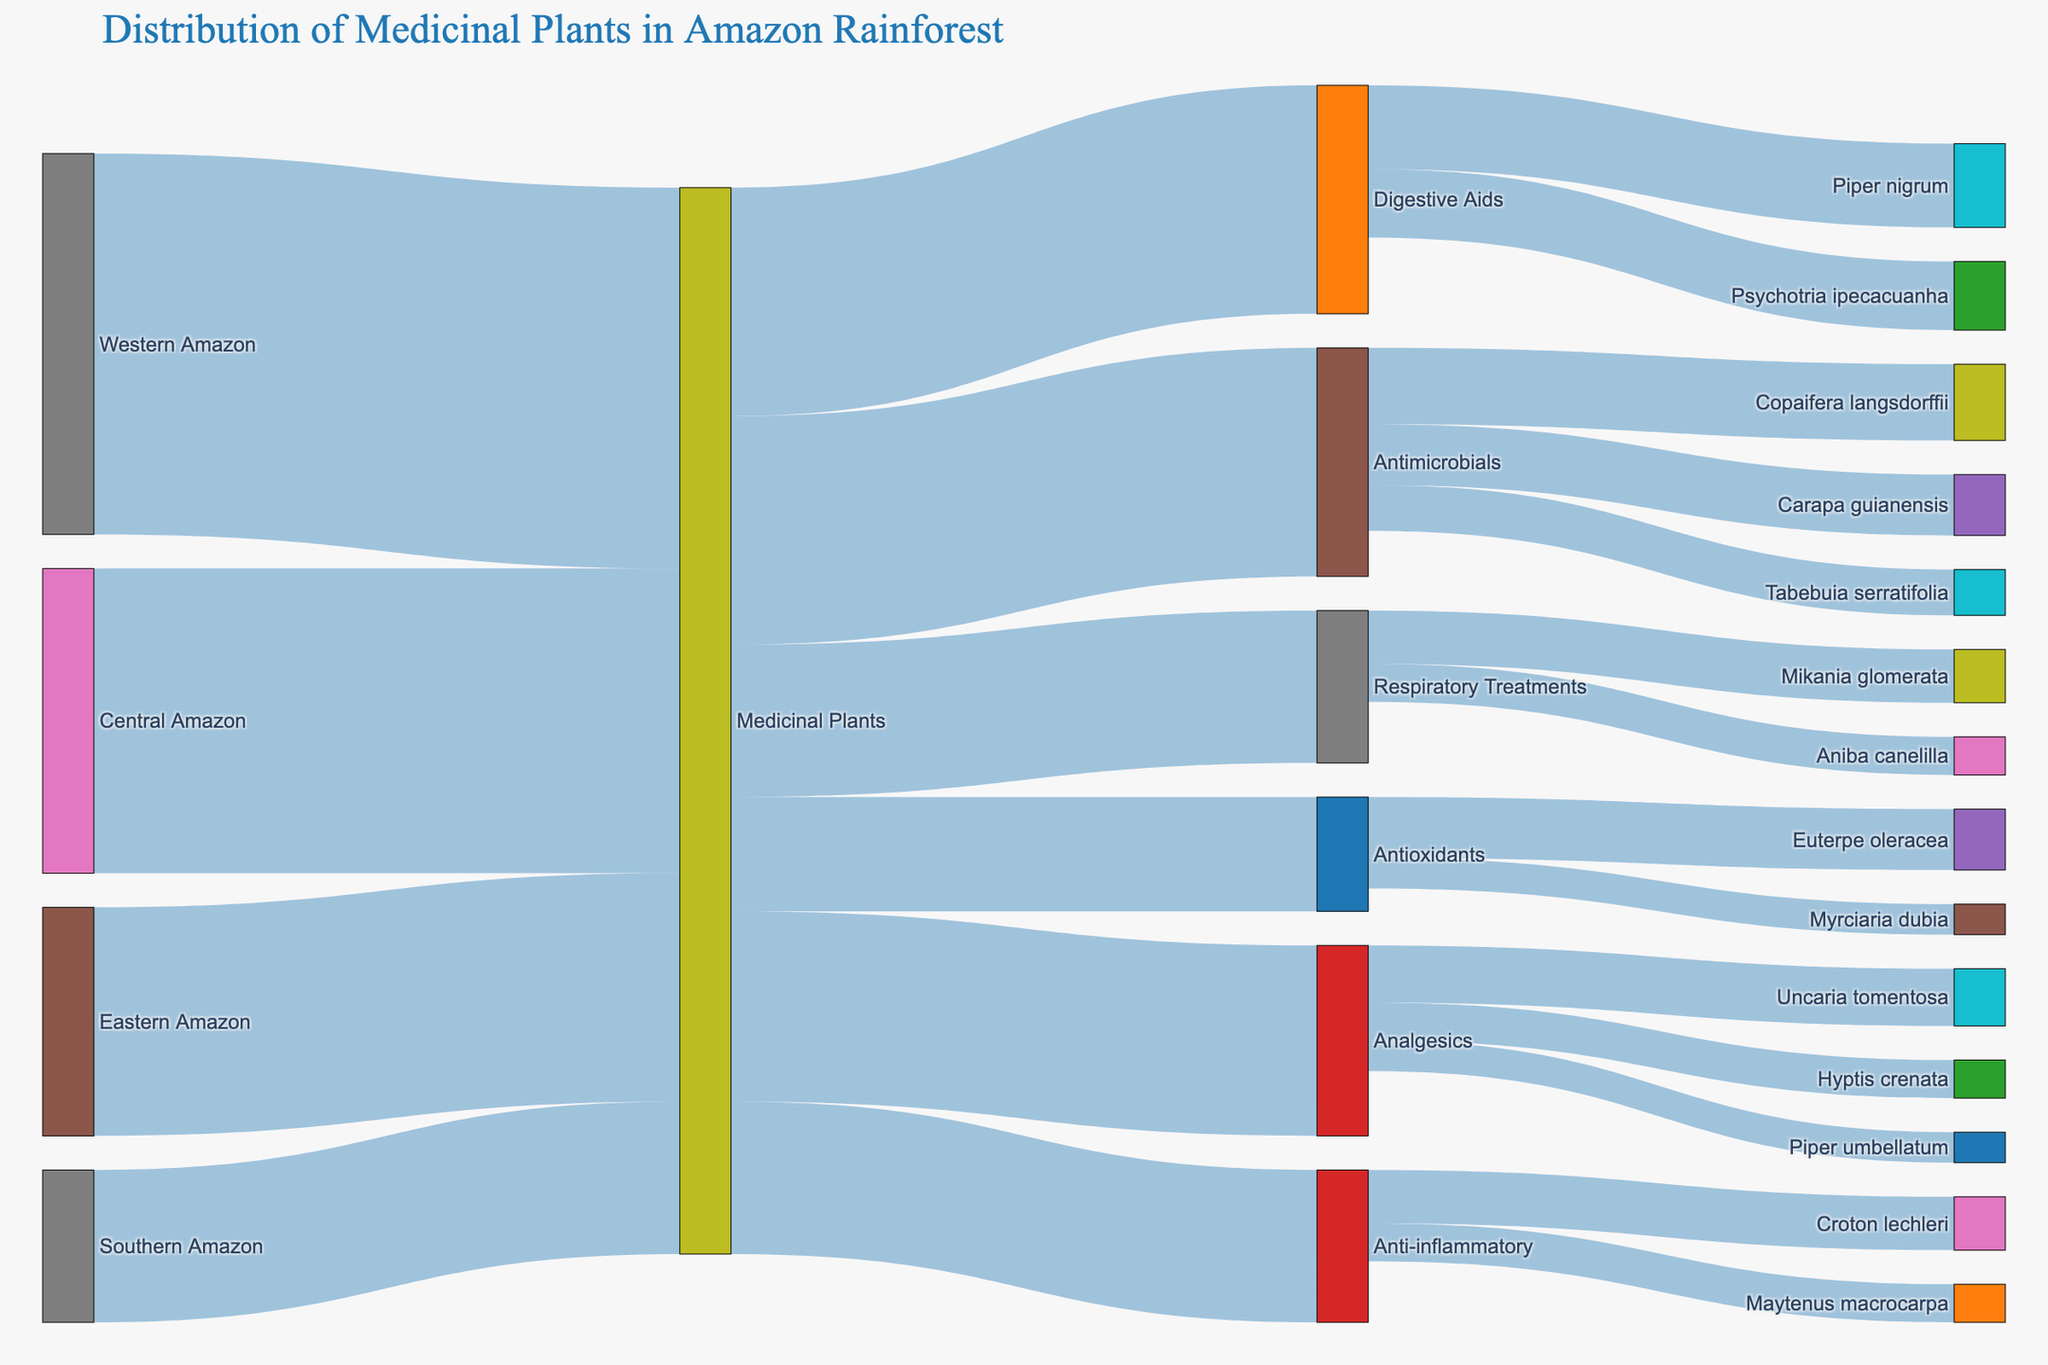What is the total number of medicinal plants identified across all regions of the Amazon rainforest? Sum up the values from Western Amazon (500), Central Amazon (400), Eastern Amazon (300), and Southern Amazon (200): 500 + 400 + 300 + 200 = 1400
Answer: 1400 Which medicinal use category has the highest number of plants associated with it? Look at the values linked to the "Medicinal Plants" node and find the highest: Analgesics (250), Antimicrobials (300), Anti-inflammatory (200), Antioxidants (150), Digestive Aids (300), Respiratory Treatments (200). The highest is Antimicrobials and Digestive Aids with both 300
Answer: Antimicrobials and Digestive Aids How many distinct plant species are used for analgesics? Count the number of target nodes connected to "Analgesics": Hyptis crenata, Uncaria tomentosa, Piper umbellatum => 3
Answer: 3 What proportion of medicinal plants from the Western Amazon are used as antimicrobials? First, note the total from Western Amazon (500). Then, look at the number of plants used as antimicrobials, connect the relevant source: Antimicrobials (300). Calculate the proportion: 300/1400 = 0.214 approx (21.4%)
Answer: 21.4% Which plant species contributes the most to respiratory treatments? Identify the largest value linked to "Respiratory Treatments": Mikania glomerata (70), Aniba canelilla (50) => The highest is Mikania glomerata with 70
Answer: Mikania glomerata Are there more plant species used for anti-inflammatory or antioxidant purposes? Count the number of direct target connections for each category: Anti-inflammatory has Croton lechleri, Maytenus macrocarpa (2); Antioxidants has Euterpe oleracea, Myrciaria dubia (2)
Answer: Equal (2 each) What is the combined total value for medicinal plants used either for digestive aids or respiratory treatments? Sum the values for Digestive Aids (300) and Respiratory Treatments (200): 300 + 200 = 500
Answer: 500 How many plant species are used in the category with the least number of plants? Identify the category with the smallest value linked to "Medicinal Plants": Antioxidants (150). Count species: Euterpe oleracea, Myrciaria dubia (2)
Answer: 2 Is there a region of the Amazon from which more than 35% of medicinal plants originate? Calculate percentages for each region: Western Amazon (500/1400 ≈ 35.7%), Central Amazon (400/1400 ≈ 28.6%), Eastern Amazon (300/1400 ≈ 21.4%), Southern Amazon (200/1400 ≈ 14.3%). The Western Amazon is just over 35%, so yes
Answer: Yes Which category has a more diverse range of plant species: analgesics or antimicrobials? Compare the number of target connections: Analgesics (3 species: Hyptis crenata, Uncaria tomentosa, Piper umbellatum), Antimicrobials (3 species: Carapa guianensis, Copaifera langsdorffii, Tabebuia serratifolia). Both have 3, so the diversity is equal
Answer: Equal 